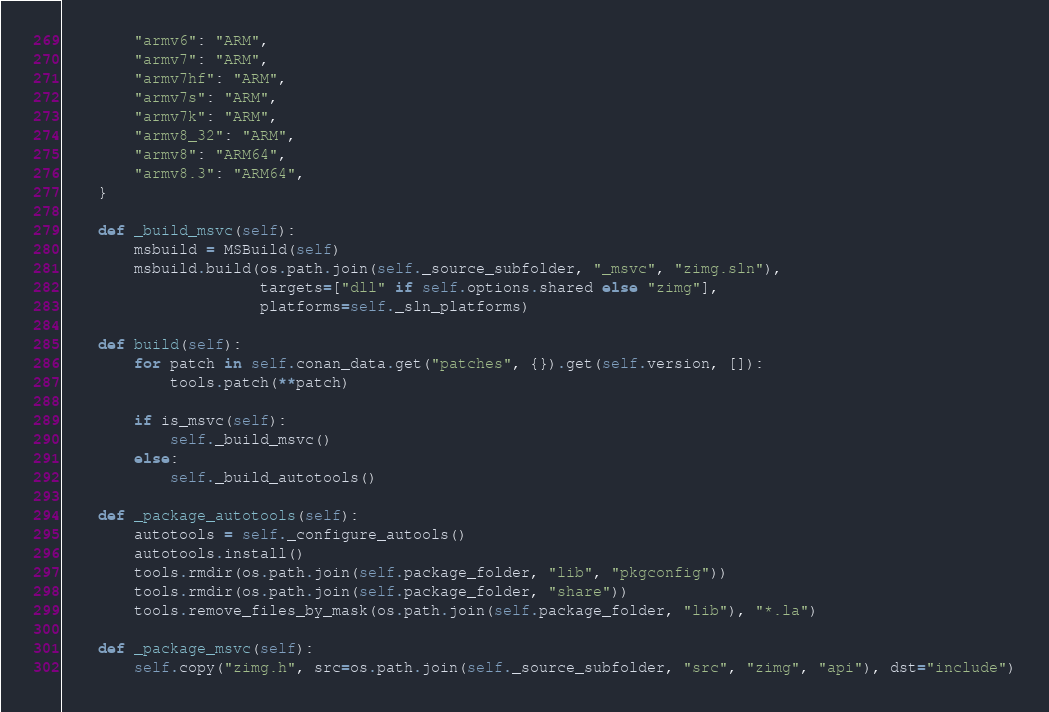<code> <loc_0><loc_0><loc_500><loc_500><_Python_>        "armv6": "ARM",
        "armv7": "ARM",
        "armv7hf": "ARM",
        "armv7s": "ARM",
        "armv7k": "ARM",
        "armv8_32": "ARM",
        "armv8": "ARM64",
        "armv8.3": "ARM64",
    }

    def _build_msvc(self):
        msbuild = MSBuild(self)
        msbuild.build(os.path.join(self._source_subfolder, "_msvc", "zimg.sln"),
                      targets=["dll" if self.options.shared else "zimg"],
                      platforms=self._sln_platforms)

    def build(self):
        for patch in self.conan_data.get("patches", {}).get(self.version, []):
            tools.patch(**patch)

        if is_msvc(self):
            self._build_msvc()
        else:
            self._build_autotools()

    def _package_autotools(self):
        autotools = self._configure_autools()
        autotools.install()
        tools.rmdir(os.path.join(self.package_folder, "lib", "pkgconfig"))
        tools.rmdir(os.path.join(self.package_folder, "share"))
        tools.remove_files_by_mask(os.path.join(self.package_folder, "lib"), "*.la")

    def _package_msvc(self):
        self.copy("zimg.h", src=os.path.join(self._source_subfolder, "src", "zimg", "api"), dst="include")</code> 